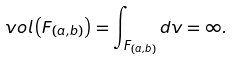<formula> <loc_0><loc_0><loc_500><loc_500>v o l \left ( F _ { ( a , b ) } \right ) = \int _ { F _ { ( a , b ) } } d v = \infty .</formula> 